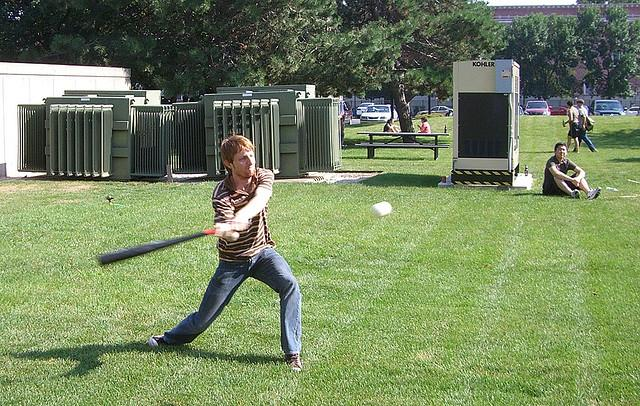What does the unit named Kohler provide?

Choices:
A) water
B) electricity
C) heat
D) air conditioning air conditioning 